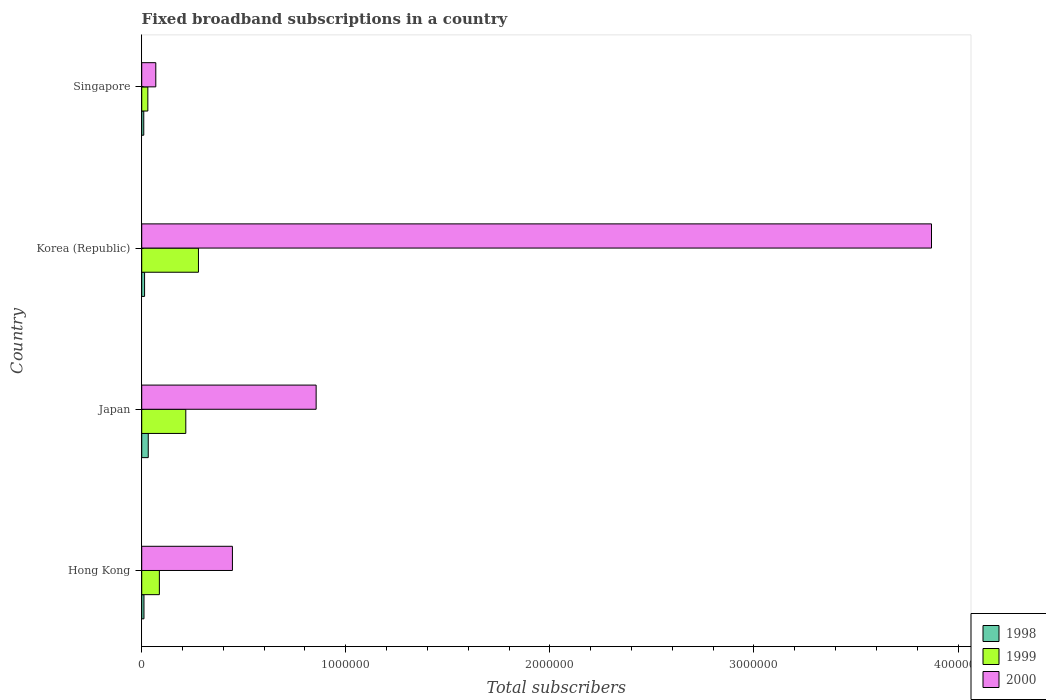How many different coloured bars are there?
Your answer should be very brief. 3. How many groups of bars are there?
Your answer should be very brief. 4. What is the label of the 4th group of bars from the top?
Give a very brief answer. Hong Kong. What is the number of broadband subscriptions in 1998 in Japan?
Make the answer very short. 3.20e+04. Across all countries, what is the maximum number of broadband subscriptions in 1998?
Ensure brevity in your answer.  3.20e+04. Across all countries, what is the minimum number of broadband subscriptions in 1998?
Ensure brevity in your answer.  10000. In which country was the number of broadband subscriptions in 2000 maximum?
Ensure brevity in your answer.  Korea (Republic). In which country was the number of broadband subscriptions in 2000 minimum?
Provide a short and direct response. Singapore. What is the total number of broadband subscriptions in 2000 in the graph?
Provide a short and direct response. 5.24e+06. What is the difference between the number of broadband subscriptions in 1999 in Hong Kong and that in Singapore?
Provide a short and direct response. 5.65e+04. What is the difference between the number of broadband subscriptions in 1999 in Hong Kong and the number of broadband subscriptions in 1998 in Korea (Republic)?
Your answer should be very brief. 7.25e+04. What is the average number of broadband subscriptions in 2000 per country?
Give a very brief answer. 1.31e+06. What is the difference between the number of broadband subscriptions in 1998 and number of broadband subscriptions in 1999 in Japan?
Your response must be concise. -1.84e+05. In how many countries, is the number of broadband subscriptions in 1999 greater than 3200000 ?
Offer a very short reply. 0. What is the difference between the highest and the second highest number of broadband subscriptions in 2000?
Provide a short and direct response. 3.02e+06. What is the difference between the highest and the lowest number of broadband subscriptions in 1998?
Provide a succinct answer. 2.20e+04. Is the sum of the number of broadband subscriptions in 2000 in Hong Kong and Singapore greater than the maximum number of broadband subscriptions in 1999 across all countries?
Give a very brief answer. Yes. What does the 1st bar from the top in Korea (Republic) represents?
Provide a short and direct response. 2000. What does the 3rd bar from the bottom in Hong Kong represents?
Keep it short and to the point. 2000. Is it the case that in every country, the sum of the number of broadband subscriptions in 1998 and number of broadband subscriptions in 2000 is greater than the number of broadband subscriptions in 1999?
Offer a very short reply. Yes. How many bars are there?
Give a very brief answer. 12. Are all the bars in the graph horizontal?
Your answer should be very brief. Yes. How many countries are there in the graph?
Offer a very short reply. 4. What is the difference between two consecutive major ticks on the X-axis?
Provide a short and direct response. 1.00e+06. Are the values on the major ticks of X-axis written in scientific E-notation?
Provide a short and direct response. No. Where does the legend appear in the graph?
Your answer should be very brief. Bottom right. How many legend labels are there?
Ensure brevity in your answer.  3. What is the title of the graph?
Give a very brief answer. Fixed broadband subscriptions in a country. Does "1967" appear as one of the legend labels in the graph?
Your answer should be compact. No. What is the label or title of the X-axis?
Give a very brief answer. Total subscribers. What is the label or title of the Y-axis?
Keep it short and to the point. Country. What is the Total subscribers of 1998 in Hong Kong?
Your answer should be compact. 1.10e+04. What is the Total subscribers of 1999 in Hong Kong?
Your response must be concise. 8.65e+04. What is the Total subscribers of 2000 in Hong Kong?
Ensure brevity in your answer.  4.44e+05. What is the Total subscribers of 1998 in Japan?
Keep it short and to the point. 3.20e+04. What is the Total subscribers of 1999 in Japan?
Your answer should be very brief. 2.16e+05. What is the Total subscribers of 2000 in Japan?
Offer a very short reply. 8.55e+05. What is the Total subscribers in 1998 in Korea (Republic)?
Make the answer very short. 1.40e+04. What is the Total subscribers of 1999 in Korea (Republic)?
Keep it short and to the point. 2.78e+05. What is the Total subscribers of 2000 in Korea (Republic)?
Provide a short and direct response. 3.87e+06. What is the Total subscribers of 2000 in Singapore?
Provide a succinct answer. 6.90e+04. Across all countries, what is the maximum Total subscribers of 1998?
Provide a succinct answer. 3.20e+04. Across all countries, what is the maximum Total subscribers of 1999?
Your response must be concise. 2.78e+05. Across all countries, what is the maximum Total subscribers of 2000?
Give a very brief answer. 3.87e+06. Across all countries, what is the minimum Total subscribers of 2000?
Provide a short and direct response. 6.90e+04. What is the total Total subscribers of 1998 in the graph?
Ensure brevity in your answer.  6.70e+04. What is the total Total subscribers in 1999 in the graph?
Your response must be concise. 6.10e+05. What is the total Total subscribers of 2000 in the graph?
Offer a terse response. 5.24e+06. What is the difference between the Total subscribers in 1998 in Hong Kong and that in Japan?
Offer a very short reply. -2.10e+04. What is the difference between the Total subscribers in 1999 in Hong Kong and that in Japan?
Make the answer very short. -1.30e+05. What is the difference between the Total subscribers of 2000 in Hong Kong and that in Japan?
Offer a very short reply. -4.10e+05. What is the difference between the Total subscribers in 1998 in Hong Kong and that in Korea (Republic)?
Provide a short and direct response. -3000. What is the difference between the Total subscribers of 1999 in Hong Kong and that in Korea (Republic)?
Provide a succinct answer. -1.92e+05. What is the difference between the Total subscribers of 2000 in Hong Kong and that in Korea (Republic)?
Your answer should be very brief. -3.43e+06. What is the difference between the Total subscribers of 1998 in Hong Kong and that in Singapore?
Offer a terse response. 1000. What is the difference between the Total subscribers of 1999 in Hong Kong and that in Singapore?
Give a very brief answer. 5.65e+04. What is the difference between the Total subscribers of 2000 in Hong Kong and that in Singapore?
Keep it short and to the point. 3.75e+05. What is the difference between the Total subscribers of 1998 in Japan and that in Korea (Republic)?
Offer a terse response. 1.80e+04. What is the difference between the Total subscribers of 1999 in Japan and that in Korea (Republic)?
Give a very brief answer. -6.20e+04. What is the difference between the Total subscribers in 2000 in Japan and that in Korea (Republic)?
Offer a terse response. -3.02e+06. What is the difference between the Total subscribers in 1998 in Japan and that in Singapore?
Offer a terse response. 2.20e+04. What is the difference between the Total subscribers of 1999 in Japan and that in Singapore?
Your response must be concise. 1.86e+05. What is the difference between the Total subscribers of 2000 in Japan and that in Singapore?
Offer a terse response. 7.86e+05. What is the difference between the Total subscribers of 1998 in Korea (Republic) and that in Singapore?
Your response must be concise. 4000. What is the difference between the Total subscribers of 1999 in Korea (Republic) and that in Singapore?
Make the answer very short. 2.48e+05. What is the difference between the Total subscribers of 2000 in Korea (Republic) and that in Singapore?
Your response must be concise. 3.80e+06. What is the difference between the Total subscribers in 1998 in Hong Kong and the Total subscribers in 1999 in Japan?
Offer a terse response. -2.05e+05. What is the difference between the Total subscribers of 1998 in Hong Kong and the Total subscribers of 2000 in Japan?
Your response must be concise. -8.44e+05. What is the difference between the Total subscribers of 1999 in Hong Kong and the Total subscribers of 2000 in Japan?
Offer a very short reply. -7.68e+05. What is the difference between the Total subscribers of 1998 in Hong Kong and the Total subscribers of 1999 in Korea (Republic)?
Offer a very short reply. -2.67e+05. What is the difference between the Total subscribers of 1998 in Hong Kong and the Total subscribers of 2000 in Korea (Republic)?
Your answer should be compact. -3.86e+06. What is the difference between the Total subscribers of 1999 in Hong Kong and the Total subscribers of 2000 in Korea (Republic)?
Your answer should be very brief. -3.78e+06. What is the difference between the Total subscribers in 1998 in Hong Kong and the Total subscribers in 1999 in Singapore?
Make the answer very short. -1.90e+04. What is the difference between the Total subscribers of 1998 in Hong Kong and the Total subscribers of 2000 in Singapore?
Provide a succinct answer. -5.80e+04. What is the difference between the Total subscribers in 1999 in Hong Kong and the Total subscribers in 2000 in Singapore?
Provide a short and direct response. 1.75e+04. What is the difference between the Total subscribers of 1998 in Japan and the Total subscribers of 1999 in Korea (Republic)?
Ensure brevity in your answer.  -2.46e+05. What is the difference between the Total subscribers of 1998 in Japan and the Total subscribers of 2000 in Korea (Republic)?
Offer a terse response. -3.84e+06. What is the difference between the Total subscribers in 1999 in Japan and the Total subscribers in 2000 in Korea (Republic)?
Provide a succinct answer. -3.65e+06. What is the difference between the Total subscribers in 1998 in Japan and the Total subscribers in 2000 in Singapore?
Provide a succinct answer. -3.70e+04. What is the difference between the Total subscribers of 1999 in Japan and the Total subscribers of 2000 in Singapore?
Your response must be concise. 1.47e+05. What is the difference between the Total subscribers of 1998 in Korea (Republic) and the Total subscribers of 1999 in Singapore?
Keep it short and to the point. -1.60e+04. What is the difference between the Total subscribers of 1998 in Korea (Republic) and the Total subscribers of 2000 in Singapore?
Provide a succinct answer. -5.50e+04. What is the difference between the Total subscribers of 1999 in Korea (Republic) and the Total subscribers of 2000 in Singapore?
Provide a short and direct response. 2.09e+05. What is the average Total subscribers in 1998 per country?
Give a very brief answer. 1.68e+04. What is the average Total subscribers in 1999 per country?
Offer a terse response. 1.53e+05. What is the average Total subscribers in 2000 per country?
Keep it short and to the point. 1.31e+06. What is the difference between the Total subscribers in 1998 and Total subscribers in 1999 in Hong Kong?
Make the answer very short. -7.55e+04. What is the difference between the Total subscribers of 1998 and Total subscribers of 2000 in Hong Kong?
Provide a short and direct response. -4.33e+05. What is the difference between the Total subscribers in 1999 and Total subscribers in 2000 in Hong Kong?
Offer a terse response. -3.58e+05. What is the difference between the Total subscribers of 1998 and Total subscribers of 1999 in Japan?
Offer a terse response. -1.84e+05. What is the difference between the Total subscribers in 1998 and Total subscribers in 2000 in Japan?
Offer a very short reply. -8.23e+05. What is the difference between the Total subscribers in 1999 and Total subscribers in 2000 in Japan?
Keep it short and to the point. -6.39e+05. What is the difference between the Total subscribers in 1998 and Total subscribers in 1999 in Korea (Republic)?
Ensure brevity in your answer.  -2.64e+05. What is the difference between the Total subscribers in 1998 and Total subscribers in 2000 in Korea (Republic)?
Your answer should be compact. -3.86e+06. What is the difference between the Total subscribers in 1999 and Total subscribers in 2000 in Korea (Republic)?
Make the answer very short. -3.59e+06. What is the difference between the Total subscribers in 1998 and Total subscribers in 1999 in Singapore?
Your response must be concise. -2.00e+04. What is the difference between the Total subscribers in 1998 and Total subscribers in 2000 in Singapore?
Your response must be concise. -5.90e+04. What is the difference between the Total subscribers in 1999 and Total subscribers in 2000 in Singapore?
Ensure brevity in your answer.  -3.90e+04. What is the ratio of the Total subscribers in 1998 in Hong Kong to that in Japan?
Offer a very short reply. 0.34. What is the ratio of the Total subscribers in 1999 in Hong Kong to that in Japan?
Keep it short and to the point. 0.4. What is the ratio of the Total subscribers of 2000 in Hong Kong to that in Japan?
Your answer should be very brief. 0.52. What is the ratio of the Total subscribers in 1998 in Hong Kong to that in Korea (Republic)?
Ensure brevity in your answer.  0.79. What is the ratio of the Total subscribers in 1999 in Hong Kong to that in Korea (Republic)?
Your answer should be compact. 0.31. What is the ratio of the Total subscribers in 2000 in Hong Kong to that in Korea (Republic)?
Your answer should be very brief. 0.11. What is the ratio of the Total subscribers in 1999 in Hong Kong to that in Singapore?
Your answer should be very brief. 2.88. What is the ratio of the Total subscribers of 2000 in Hong Kong to that in Singapore?
Offer a very short reply. 6.44. What is the ratio of the Total subscribers in 1998 in Japan to that in Korea (Republic)?
Your answer should be compact. 2.29. What is the ratio of the Total subscribers of 1999 in Japan to that in Korea (Republic)?
Give a very brief answer. 0.78. What is the ratio of the Total subscribers of 2000 in Japan to that in Korea (Republic)?
Provide a succinct answer. 0.22. What is the ratio of the Total subscribers of 2000 in Japan to that in Singapore?
Your answer should be very brief. 12.39. What is the ratio of the Total subscribers in 1998 in Korea (Republic) to that in Singapore?
Offer a very short reply. 1.4. What is the ratio of the Total subscribers of 1999 in Korea (Republic) to that in Singapore?
Give a very brief answer. 9.27. What is the ratio of the Total subscribers in 2000 in Korea (Republic) to that in Singapore?
Provide a succinct answer. 56.09. What is the difference between the highest and the second highest Total subscribers in 1998?
Offer a terse response. 1.80e+04. What is the difference between the highest and the second highest Total subscribers of 1999?
Your answer should be compact. 6.20e+04. What is the difference between the highest and the second highest Total subscribers of 2000?
Make the answer very short. 3.02e+06. What is the difference between the highest and the lowest Total subscribers of 1998?
Your answer should be compact. 2.20e+04. What is the difference between the highest and the lowest Total subscribers of 1999?
Your response must be concise. 2.48e+05. What is the difference between the highest and the lowest Total subscribers in 2000?
Your response must be concise. 3.80e+06. 